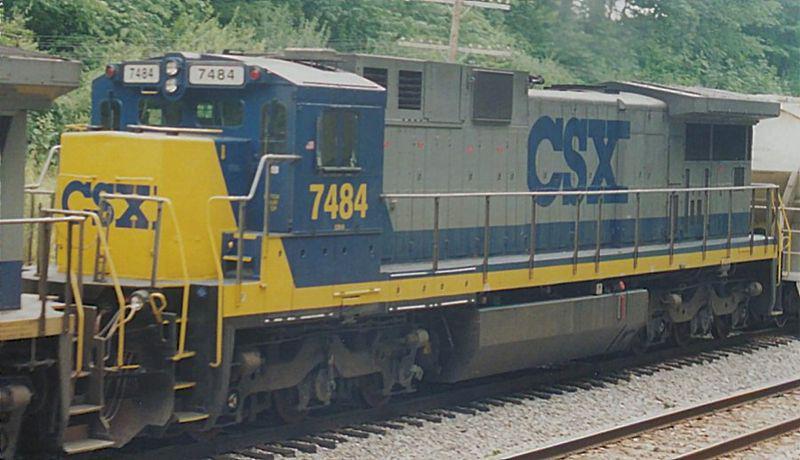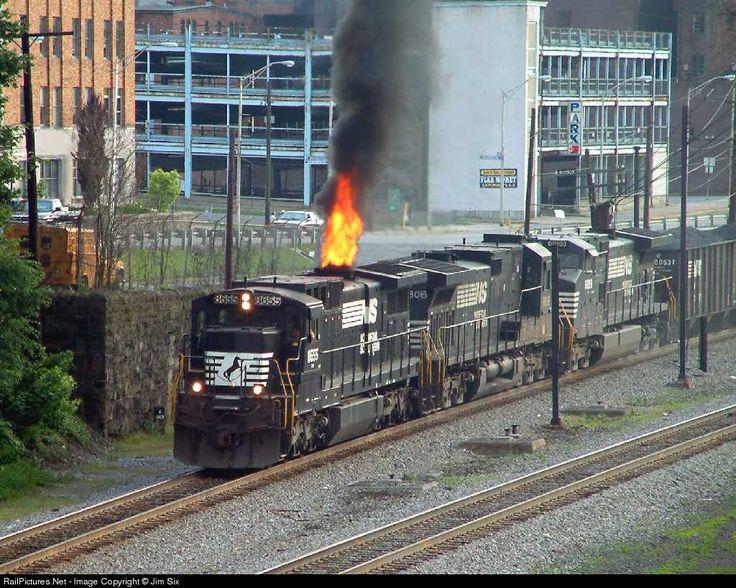The first image is the image on the left, the second image is the image on the right. Analyze the images presented: Is the assertion "A train has a bright yellow front and faces leftward." valid? Answer yes or no. Yes. 